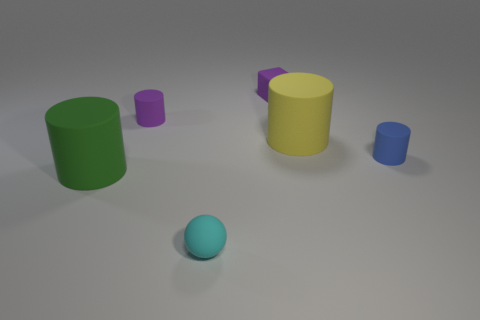Add 4 big cylinders. How many objects exist? 10 Subtract all large yellow cylinders. How many cylinders are left? 3 Subtract all yellow cylinders. How many cylinders are left? 3 Subtract 2 cylinders. How many cylinders are left? 2 Subtract all cylinders. How many objects are left? 2 Add 1 tiny blocks. How many tiny blocks are left? 2 Add 6 small purple matte cylinders. How many small purple matte cylinders exist? 7 Subtract 1 yellow cylinders. How many objects are left? 5 Subtract all brown cylinders. Subtract all brown balls. How many cylinders are left? 4 Subtract all small cubes. Subtract all small rubber cylinders. How many objects are left? 3 